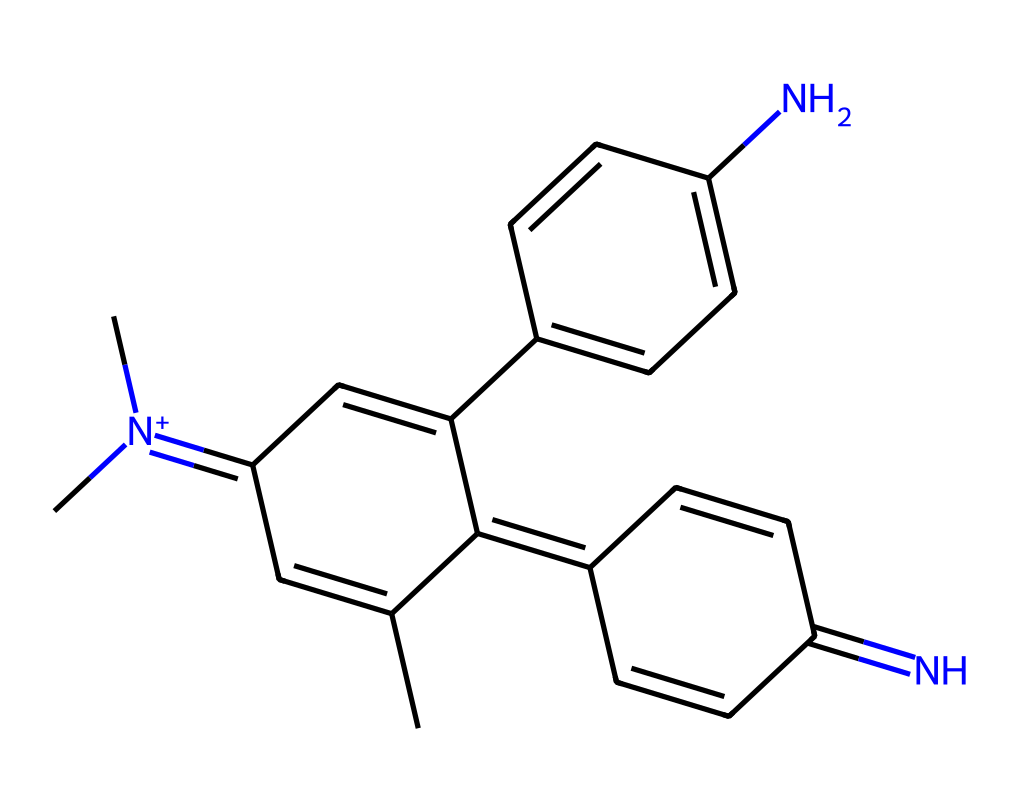What is the primary functional group in this aniline dye? The structure includes an amino group (-NH2) attached to an aromatic system, indicating the presence of an amine functional group.
Answer: amino group How many nitrogen atoms are present in this structure? By analyzing the SMILES representation, two distinct nitrogen atoms can be identified, one in the amino group and the other in a positively charged aromatic ring.
Answer: 2 What type of dye does this structure represent? The presence of an aniline group and multiple aromatic rings classify this compound as an aniline dye, which is known for its vibrant colors used in textiles.
Answer: aniline dye Which part of the structure contributes primarily to its color? The conjugated system of double bonds within the aromatic rings allows for electron delocalization, which is responsible for the vivid coloration of the dye.
Answer: conjugated system What is the total number of carbon atoms in this molecule? By counting the carbon symbols in the SMILES structure, both those in the chains and rings, a total of eighteen carbon atoms can be determined.
Answer: 18 How does the presence of nitrogen atoms affect the properties of this dye? The presence of nitrogen in the amino group enhances solubility in water and influences dyeing properties, as nitrogen can form coordination bonds with various substrates.
Answer: enhances solubility 